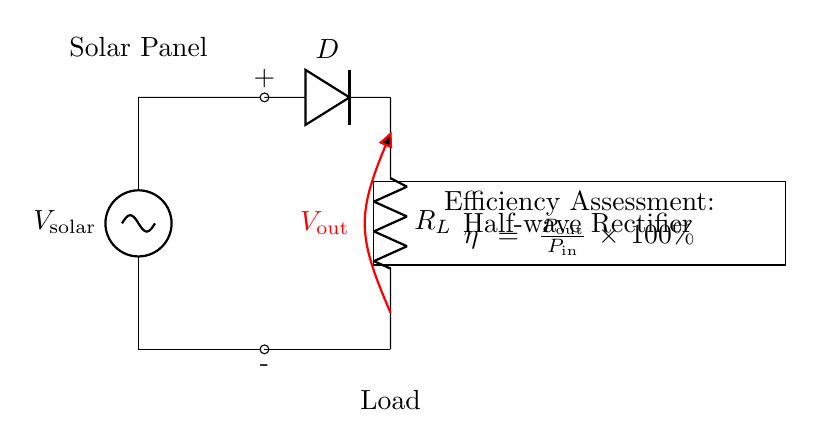What is the input voltage in this circuit? The input voltage is labeled as V solar, which represents the voltage provided by the solar panel.
Answer: V solar What component functions as the rectifier in this circuit? The component that rectifies the current is labeled as D, which corresponds to a diode.
Answer: Diode What is the output voltage across the load resistor? The output voltage is noted as V out, which is the voltage measured across the load resistor in the circuit.
Answer: V out What type of rectifier is used in this circuit? The circuit is specifically indicated as a half-wave rectifier, meaning it allows only one half of the input signal to pass through.
Answer: Half-wave rectifier How is the efficiency of this circuit calculated? The efficiency is calculated using the formula η = P out / P in × 100%, where P out is the output power and P in is the input power.
Answer: η = P out / P in × 100% What is the purpose of the load resistor in the circuit? The load resistor (labeled R L) is used to consume power and thus produce usable output voltage from the rectified current.
Answer: To consume power Why is a diode used in the half-wave rectifier? The diode allows current to flow in only one direction, which is essential for converting AC (alternating current) to DC (direct current) in a half-wave rectifier setup.
Answer: To allow one-directional current flow 